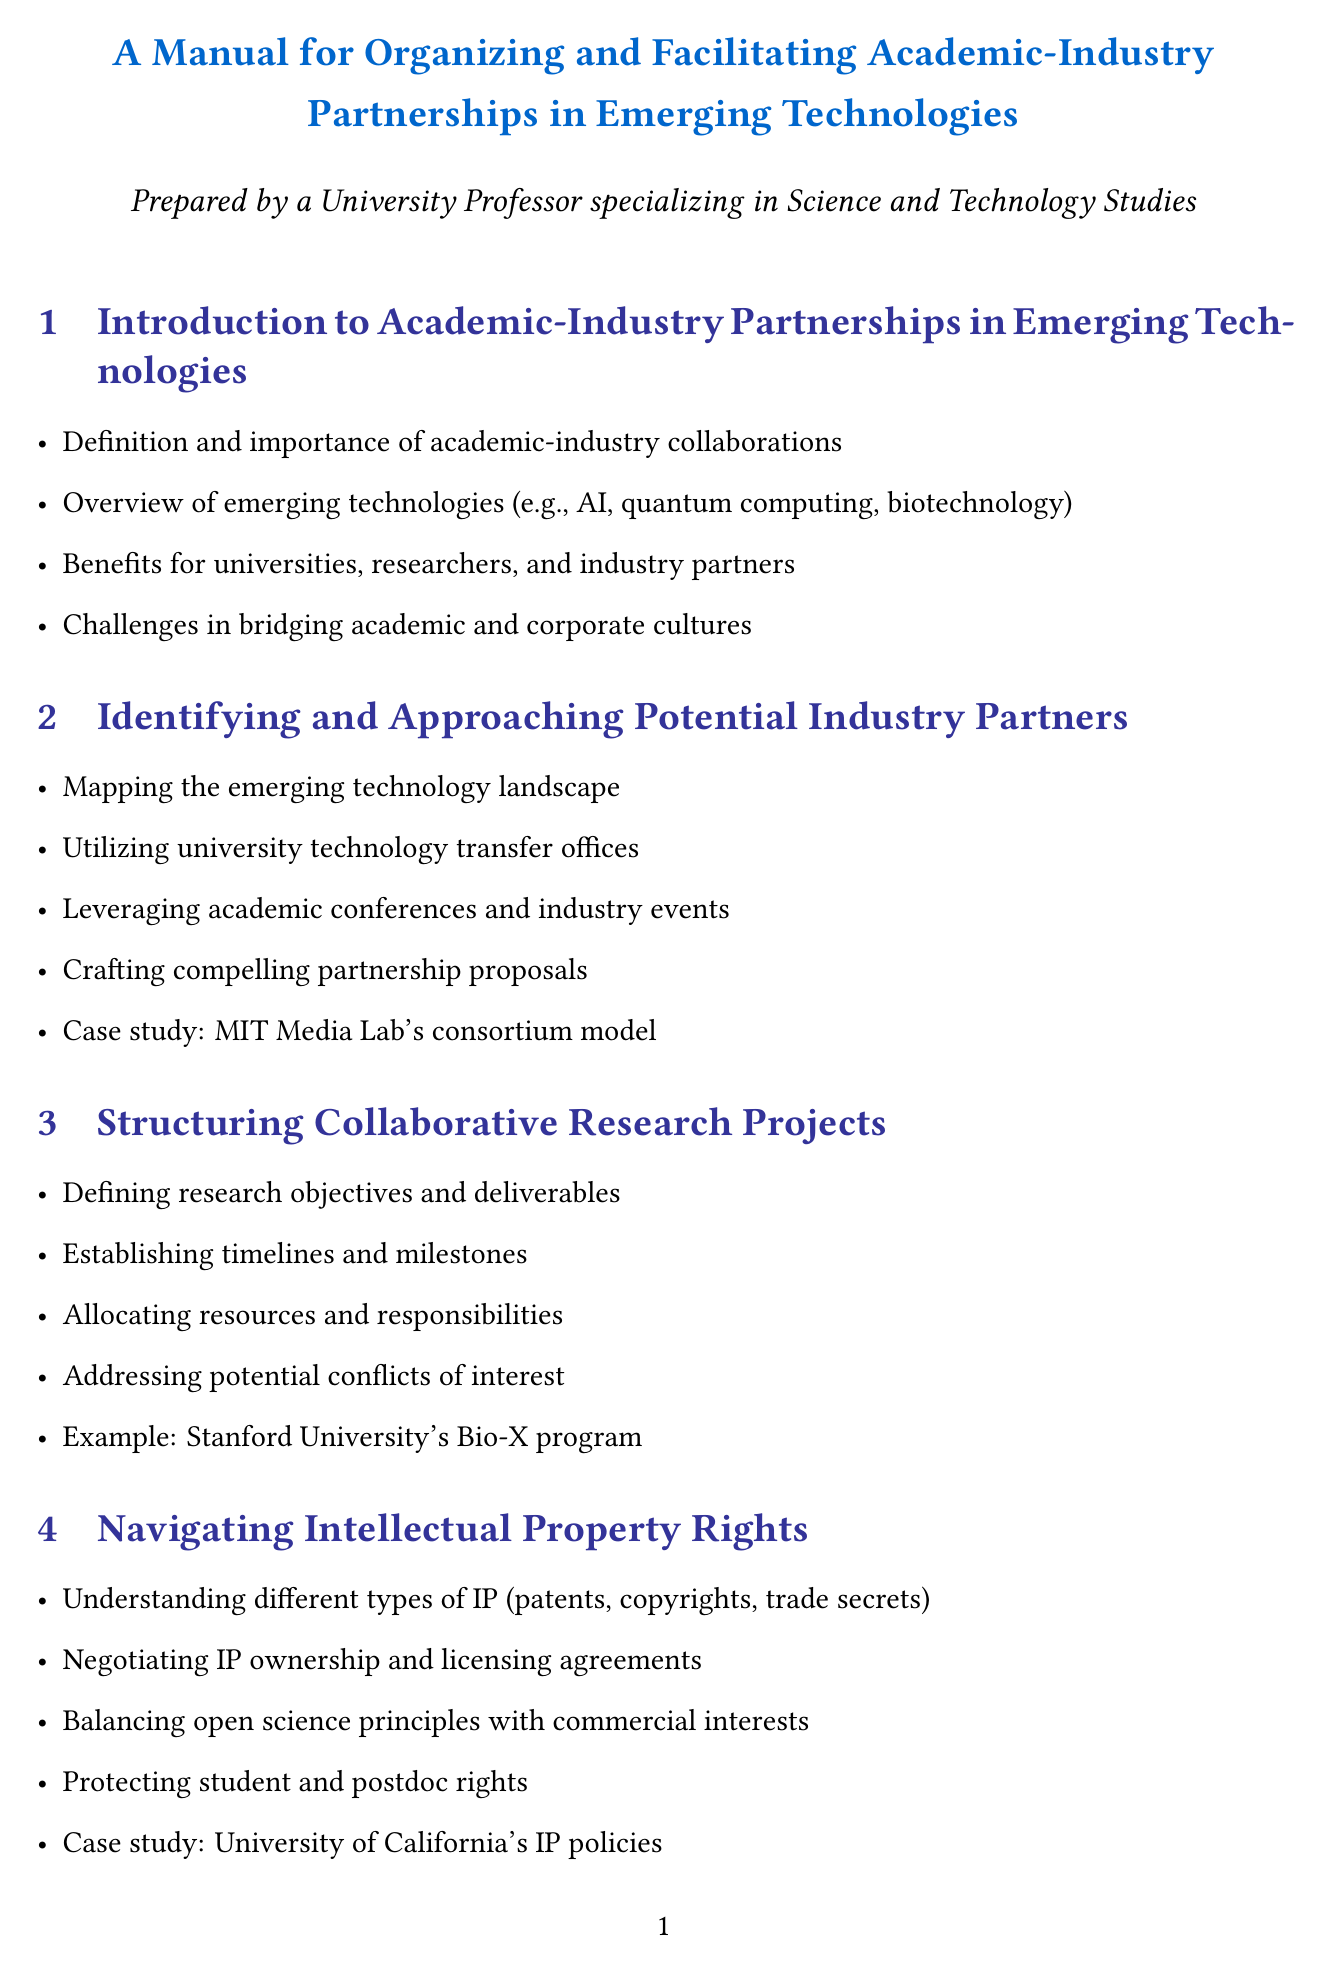What is the importance of academic-industry collaborations? The manual states the definition and importance of academic-industry collaborations in the introduction section.
Answer: Importance of academic-industry collaborations What is an example of an academic program mentioned in the funding section? The manual provides an example of Georgia Tech's VentureLab program in the funding opportunities section.
Answer: Georgia Tech's VentureLab program What is a key ethical consideration in academic-industry partnerships? The manual outlines maintaining academic integrity and research autonomy as a key ethical consideration.
Answer: Maintaining academic integrity and research autonomy What types of IP are discussed in the intellectual property section? The manual lists different types of intellectual property mentioned in the relevant section.
Answer: Patents, copyrights, trade secrets What is a case study mentioned for communication strategies? The manual references IBM's Quantum Network academic partnerships as a case study in the communication section.
Answer: IBM's Quantum Network academic partnerships How many sections are in the manual? The manual contains ten sections, covering various aspects of academic-industry partnerships.
Answer: Ten sections What is the focus of the last section of the manual? The last section of the manual discusses STS perspectives on academic-industry collaborations.
Answer: STS perspectives on academic-industry collaborations What is one potential challenge described in academic-industry partnerships? The manual mentions challenges in bridging academic and corporate cultures in the introduction.
Answer: Bridging academic and corporate cultures What should be defined to measure partnership success? The manual emphasizes defining key performance indicators to measure partnership success.
Answer: Key performance indicators 